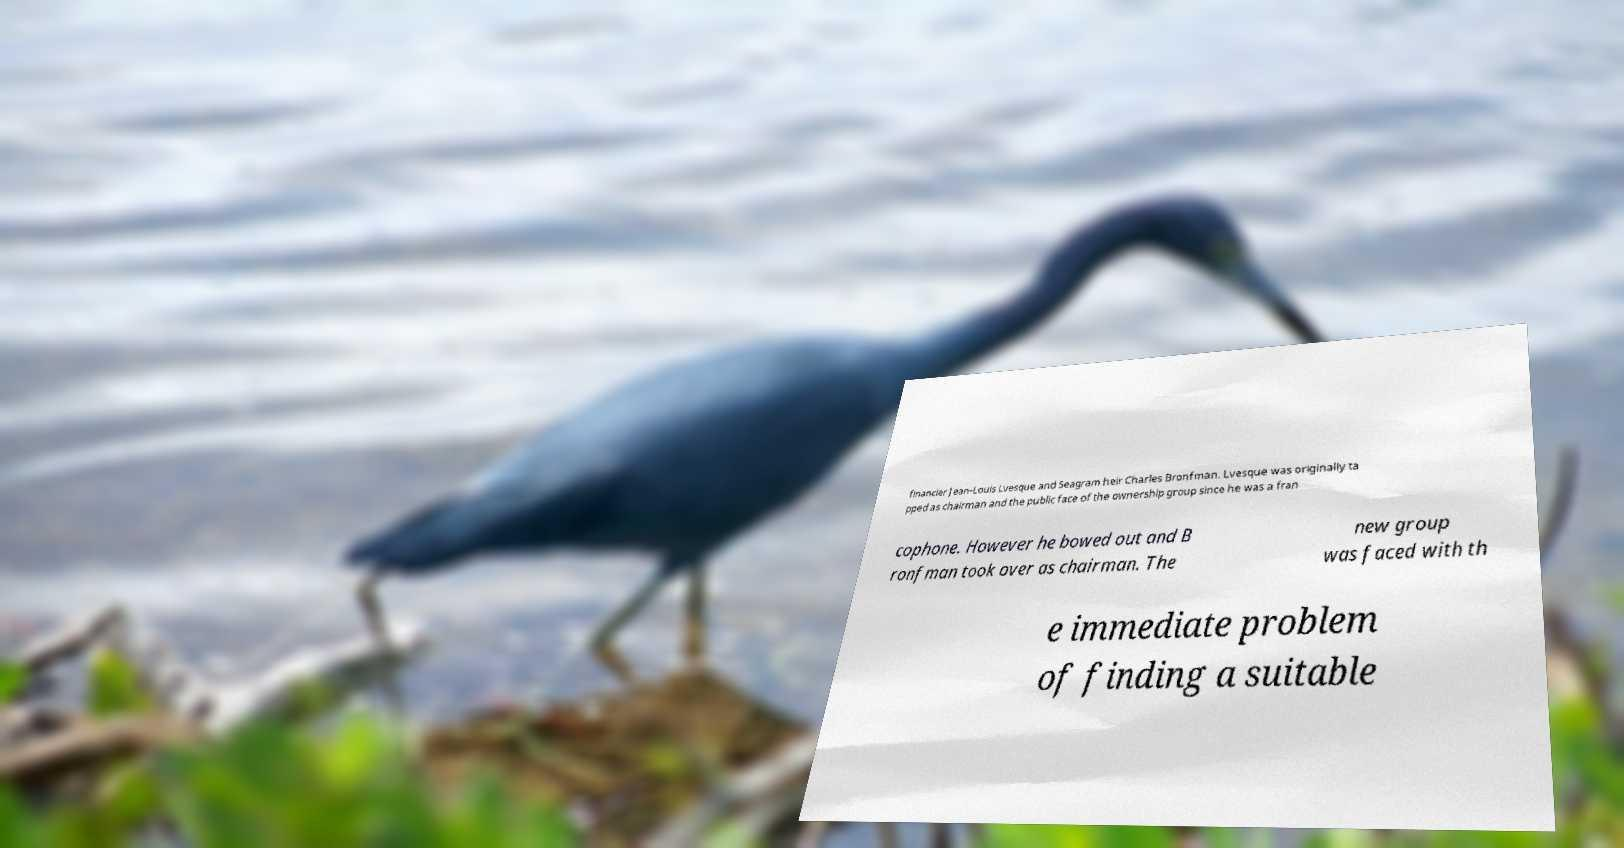There's text embedded in this image that I need extracted. Can you transcribe it verbatim? financier Jean-Louis Lvesque and Seagram heir Charles Bronfman. Lvesque was originally ta pped as chairman and the public face of the ownership group since he was a fran cophone. However he bowed out and B ronfman took over as chairman. The new group was faced with th e immediate problem of finding a suitable 